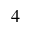<formula> <loc_0><loc_0><loc_500><loc_500>4</formula> 